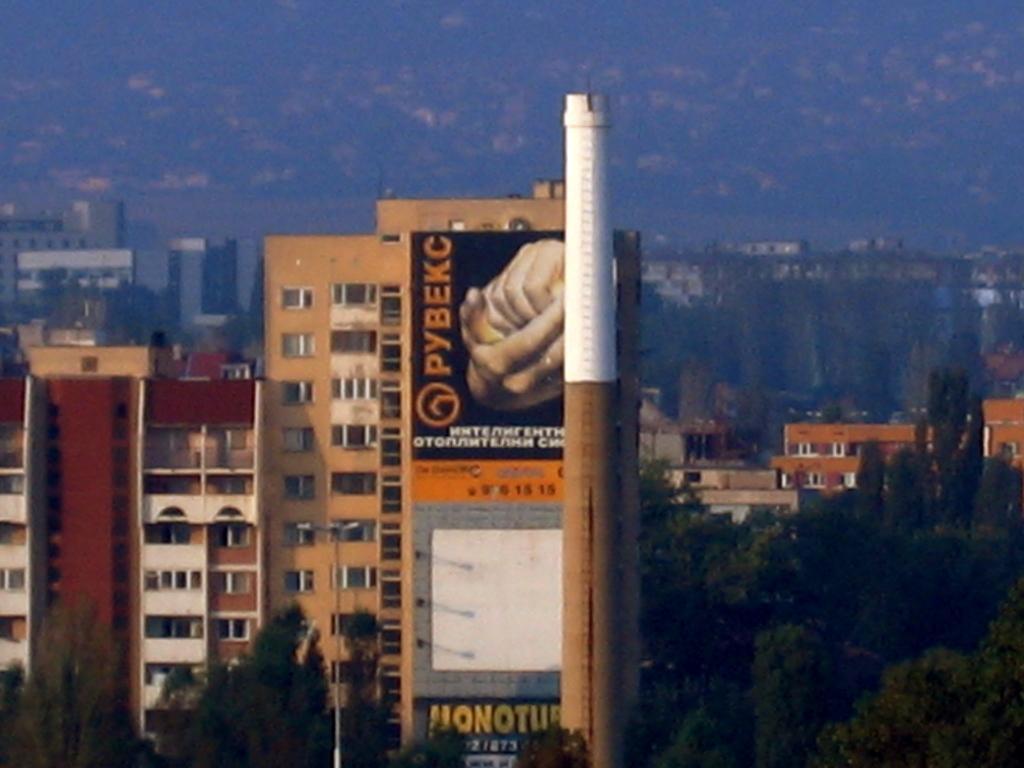Can you describe this image briefly? There are buildings, trees, a tower and a poster in the foreground area of the image, there are buildings in the background. 